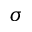<formula> <loc_0><loc_0><loc_500><loc_500>\sigma</formula> 